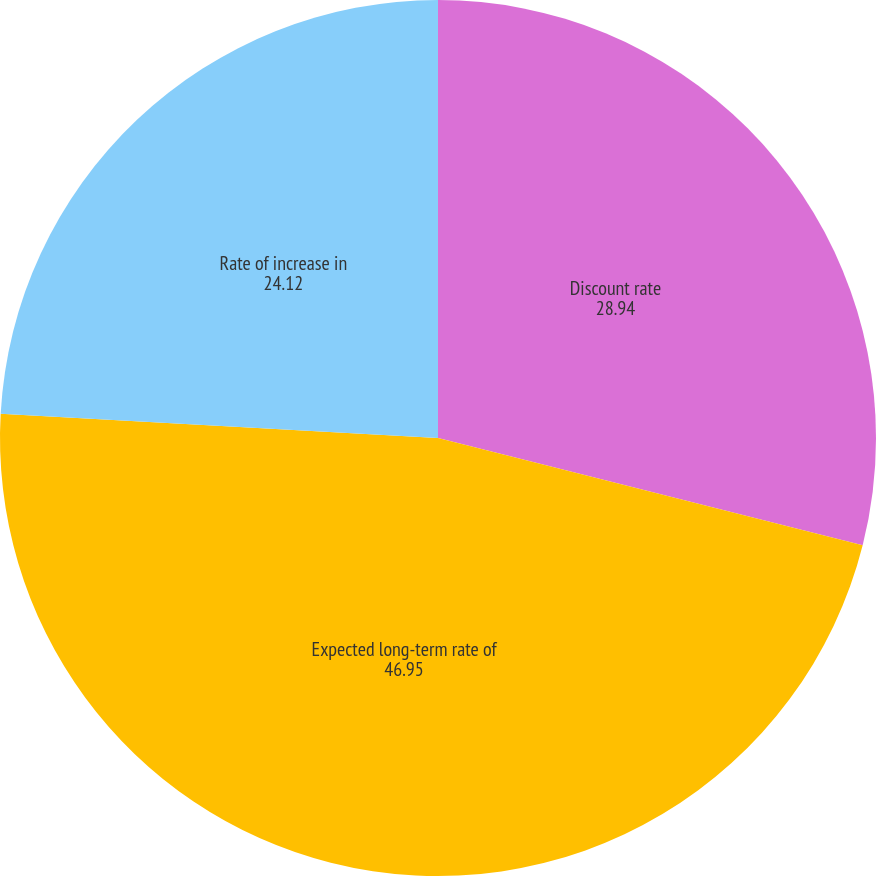Convert chart to OTSL. <chart><loc_0><loc_0><loc_500><loc_500><pie_chart><fcel>Discount rate<fcel>Expected long-term rate of<fcel>Rate of increase in<nl><fcel>28.94%<fcel>46.95%<fcel>24.12%<nl></chart> 